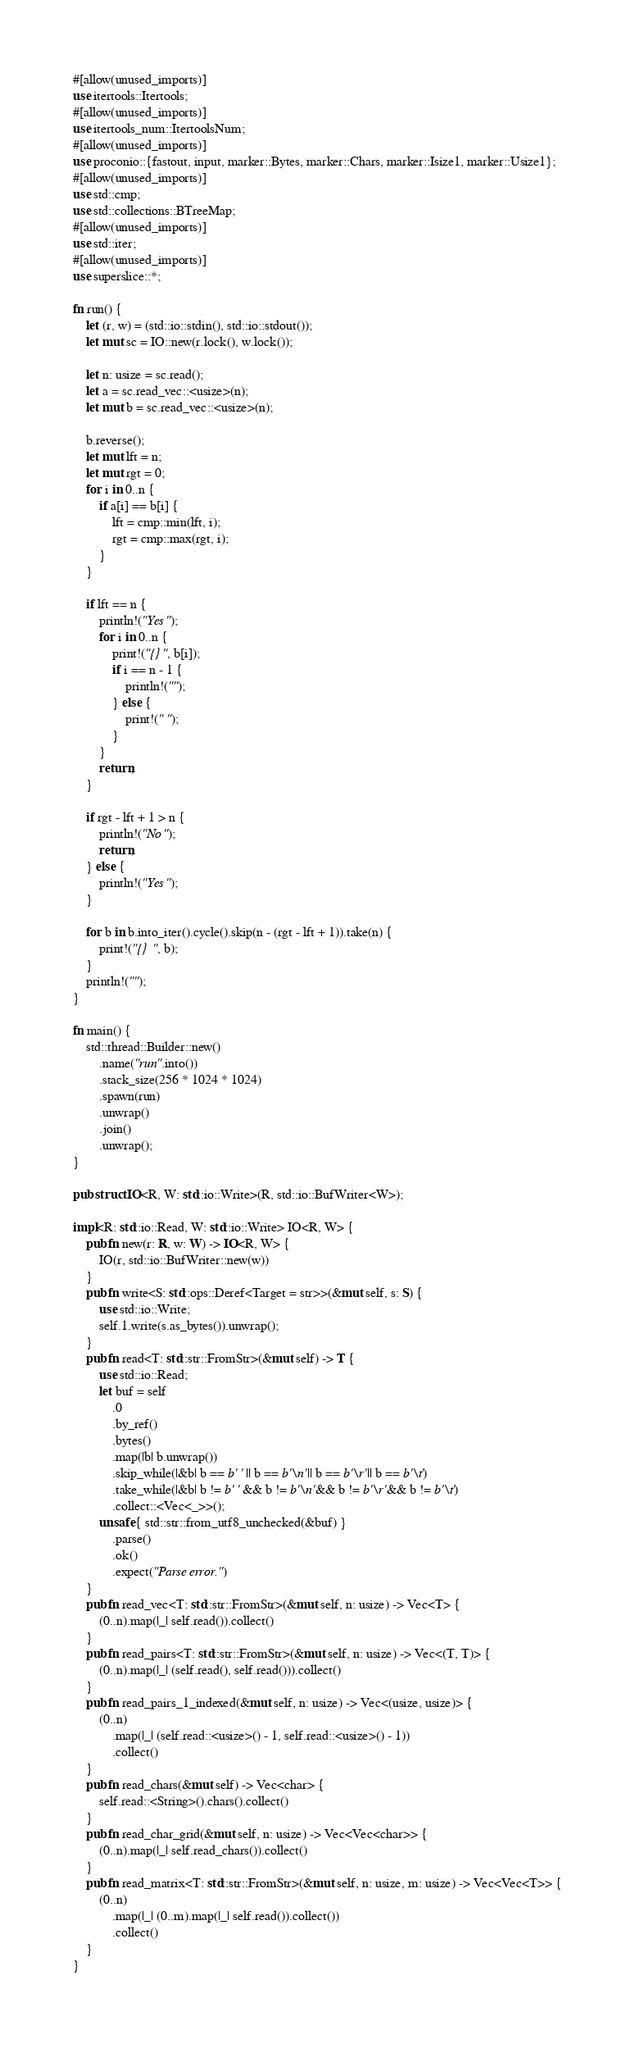<code> <loc_0><loc_0><loc_500><loc_500><_Rust_>#[allow(unused_imports)]
use itertools::Itertools;
#[allow(unused_imports)]
use itertools_num::ItertoolsNum;
#[allow(unused_imports)]
use proconio::{fastout, input, marker::Bytes, marker::Chars, marker::Isize1, marker::Usize1};
#[allow(unused_imports)]
use std::cmp;
use std::collections::BTreeMap;
#[allow(unused_imports)]
use std::iter;
#[allow(unused_imports)]
use superslice::*;

fn run() {
    let (r, w) = (std::io::stdin(), std::io::stdout());
    let mut sc = IO::new(r.lock(), w.lock());

    let n: usize = sc.read();
    let a = sc.read_vec::<usize>(n);
    let mut b = sc.read_vec::<usize>(n);

    b.reverse();
    let mut lft = n;
    let mut rgt = 0;
    for i in 0..n {
        if a[i] == b[i] {
            lft = cmp::min(lft, i);
            rgt = cmp::max(rgt, i);
        }
    }

    if lft == n {
        println!("Yes");
        for i in 0..n {
            print!("{}", b[i]);
            if i == n - 1 {
                println!("");
            } else {
                print!(" ");
            }
        }
        return;
    }

    if rgt - lft + 1 > n {
        println!("No");
        return;
    } else {
        println!("Yes");
    }

    for b in b.into_iter().cycle().skip(n - (rgt - lft + 1)).take(n) {
        print!("{} ", b);
    }
    println!("");
}

fn main() {
    std::thread::Builder::new()
        .name("run".into())
        .stack_size(256 * 1024 * 1024)
        .spawn(run)
        .unwrap()
        .join()
        .unwrap();
}

pub struct IO<R, W: std::io::Write>(R, std::io::BufWriter<W>);

impl<R: std::io::Read, W: std::io::Write> IO<R, W> {
    pub fn new(r: R, w: W) -> IO<R, W> {
        IO(r, std::io::BufWriter::new(w))
    }
    pub fn write<S: std::ops::Deref<Target = str>>(&mut self, s: S) {
        use std::io::Write;
        self.1.write(s.as_bytes()).unwrap();
    }
    pub fn read<T: std::str::FromStr>(&mut self) -> T {
        use std::io::Read;
        let buf = self
            .0
            .by_ref()
            .bytes()
            .map(|b| b.unwrap())
            .skip_while(|&b| b == b' ' || b == b'\n' || b == b'\r' || b == b'\t')
            .take_while(|&b| b != b' ' && b != b'\n' && b != b'\r' && b != b'\t')
            .collect::<Vec<_>>();
        unsafe { std::str::from_utf8_unchecked(&buf) }
            .parse()
            .ok()
            .expect("Parse error.")
    }
    pub fn read_vec<T: std::str::FromStr>(&mut self, n: usize) -> Vec<T> {
        (0..n).map(|_| self.read()).collect()
    }
    pub fn read_pairs<T: std::str::FromStr>(&mut self, n: usize) -> Vec<(T, T)> {
        (0..n).map(|_| (self.read(), self.read())).collect()
    }
    pub fn read_pairs_1_indexed(&mut self, n: usize) -> Vec<(usize, usize)> {
        (0..n)
            .map(|_| (self.read::<usize>() - 1, self.read::<usize>() - 1))
            .collect()
    }
    pub fn read_chars(&mut self) -> Vec<char> {
        self.read::<String>().chars().collect()
    }
    pub fn read_char_grid(&mut self, n: usize) -> Vec<Vec<char>> {
        (0..n).map(|_| self.read_chars()).collect()
    }
    pub fn read_matrix<T: std::str::FromStr>(&mut self, n: usize, m: usize) -> Vec<Vec<T>> {
        (0..n)
            .map(|_| (0..m).map(|_| self.read()).collect())
            .collect()
    }
}
</code> 